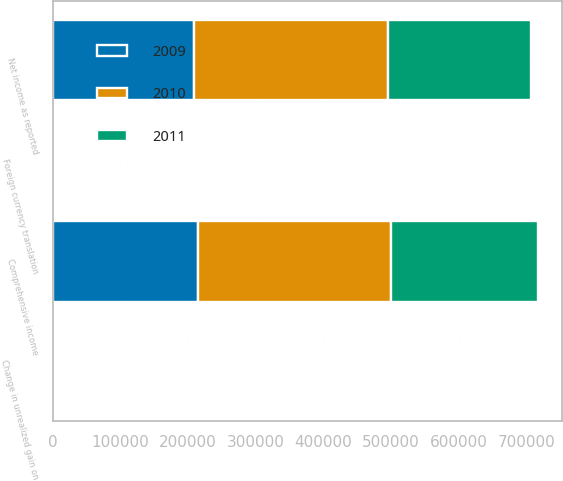Convert chart to OTSL. <chart><loc_0><loc_0><loc_500><loc_500><stacked_bar_chart><ecel><fcel>Net income as reported<fcel>Change in unrealized gain on<fcel>Foreign currency translation<fcel>Comprehensive income<nl><fcel>2010<fcel>286219<fcel>1478<fcel>3306<fcel>284391<nl><fcel>2011<fcel>212029<fcel>3111<fcel>1837<fcel>216977<nl><fcel>2009<fcel>208716<fcel>4071<fcel>2087<fcel>214874<nl></chart> 